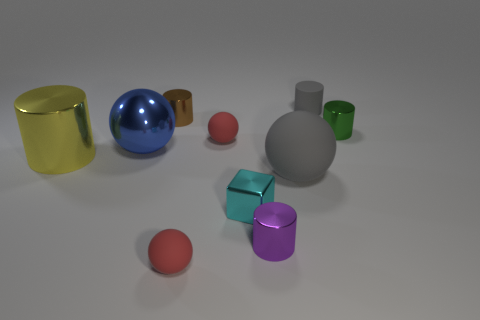What color is the sphere that is made of the same material as the brown cylinder?
Your response must be concise. Blue. How many purple things are the same size as the yellow cylinder?
Make the answer very short. 0. Is the red object behind the big gray rubber sphere made of the same material as the big gray object?
Provide a short and direct response. Yes. Is the number of yellow metallic cylinders behind the green cylinder less than the number of tiny purple shiny objects?
Offer a terse response. Yes. There is a matte thing that is behind the green metal object; what shape is it?
Your answer should be very brief. Cylinder. There is a yellow metallic thing that is the same size as the metallic sphere; what shape is it?
Provide a succinct answer. Cylinder. Is there a large blue object of the same shape as the purple thing?
Offer a very short reply. No. Does the gray matte thing that is on the right side of the gray ball have the same shape as the large object that is left of the big metal sphere?
Keep it short and to the point. Yes. There is a cylinder that is the same size as the metal sphere; what is its material?
Give a very brief answer. Metal. How many other things are there of the same material as the green thing?
Offer a very short reply. 5. 